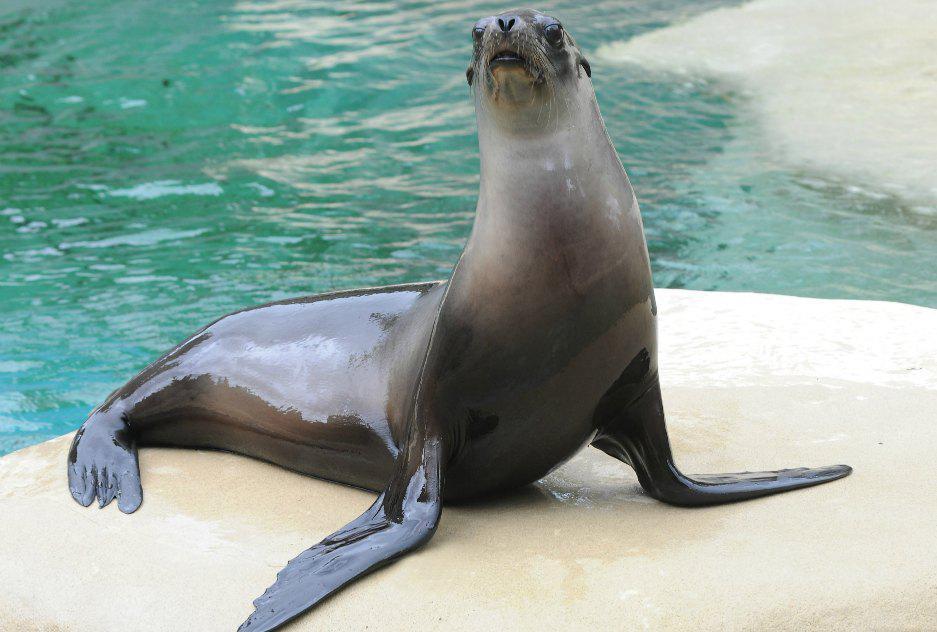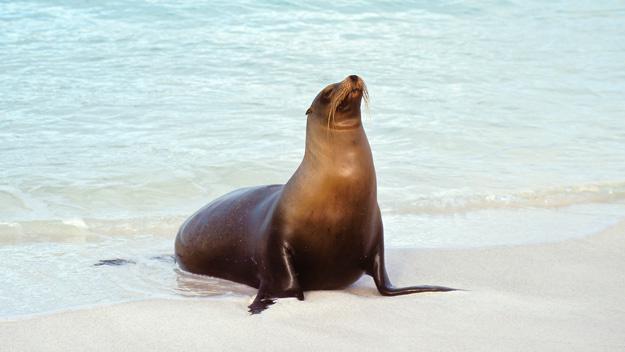The first image is the image on the left, the second image is the image on the right. Assess this claim about the two images: "There are seals underwater". Correct or not? Answer yes or no. No. The first image is the image on the left, the second image is the image on the right. Given the left and right images, does the statement "There is no less than one seal swimming underwater" hold true? Answer yes or no. No. 